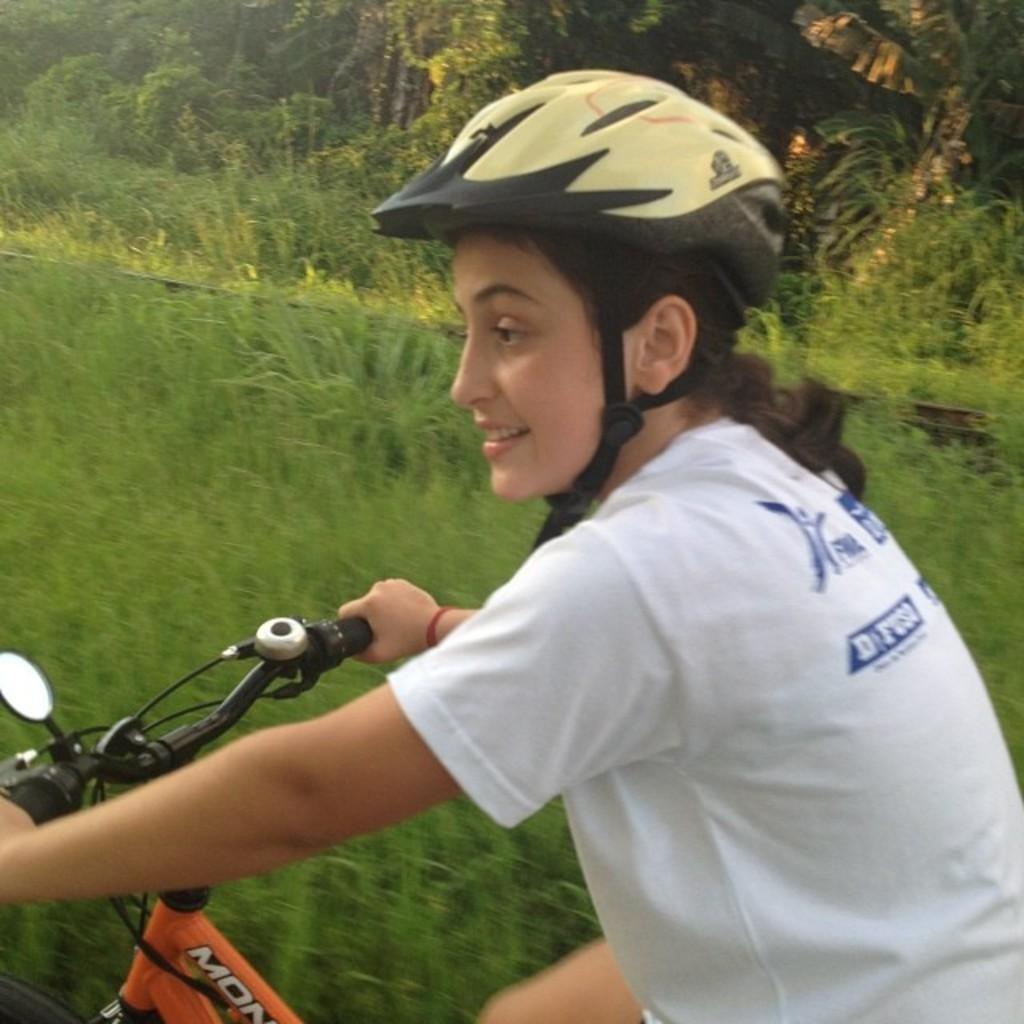What is the person in the image doing? The person is riding a bicycle. What is the person wearing while riding the bicycle? The person is wearing a helmet. What can be seen in the background of the image? There is grass and plants in the background of the image. What scientific discovery is the person making while riding the bicycle in the image? There is no indication of a scientific discovery being made in the image; the person is simply riding a bicycle. 